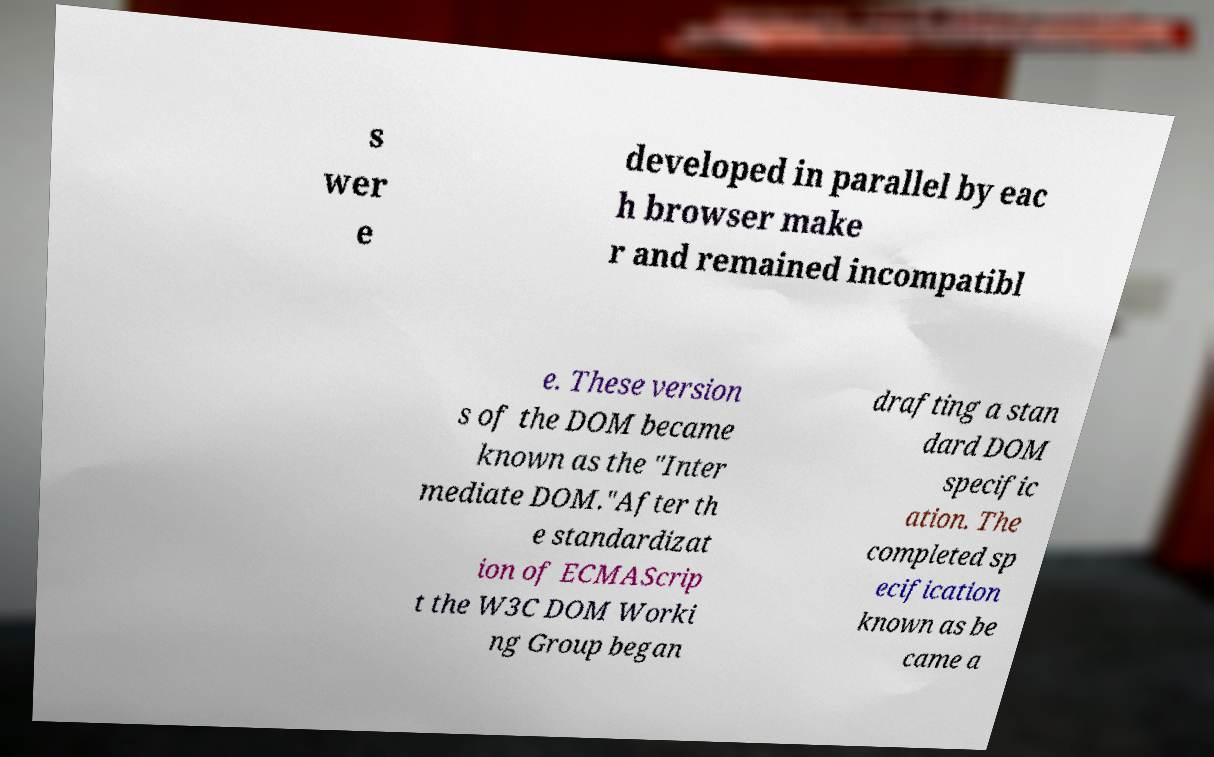What messages or text are displayed in this image? I need them in a readable, typed format. s wer e developed in parallel by eac h browser make r and remained incompatibl e. These version s of the DOM became known as the "Inter mediate DOM."After th e standardizat ion of ECMAScrip t the W3C DOM Worki ng Group began drafting a stan dard DOM specific ation. The completed sp ecification known as be came a 